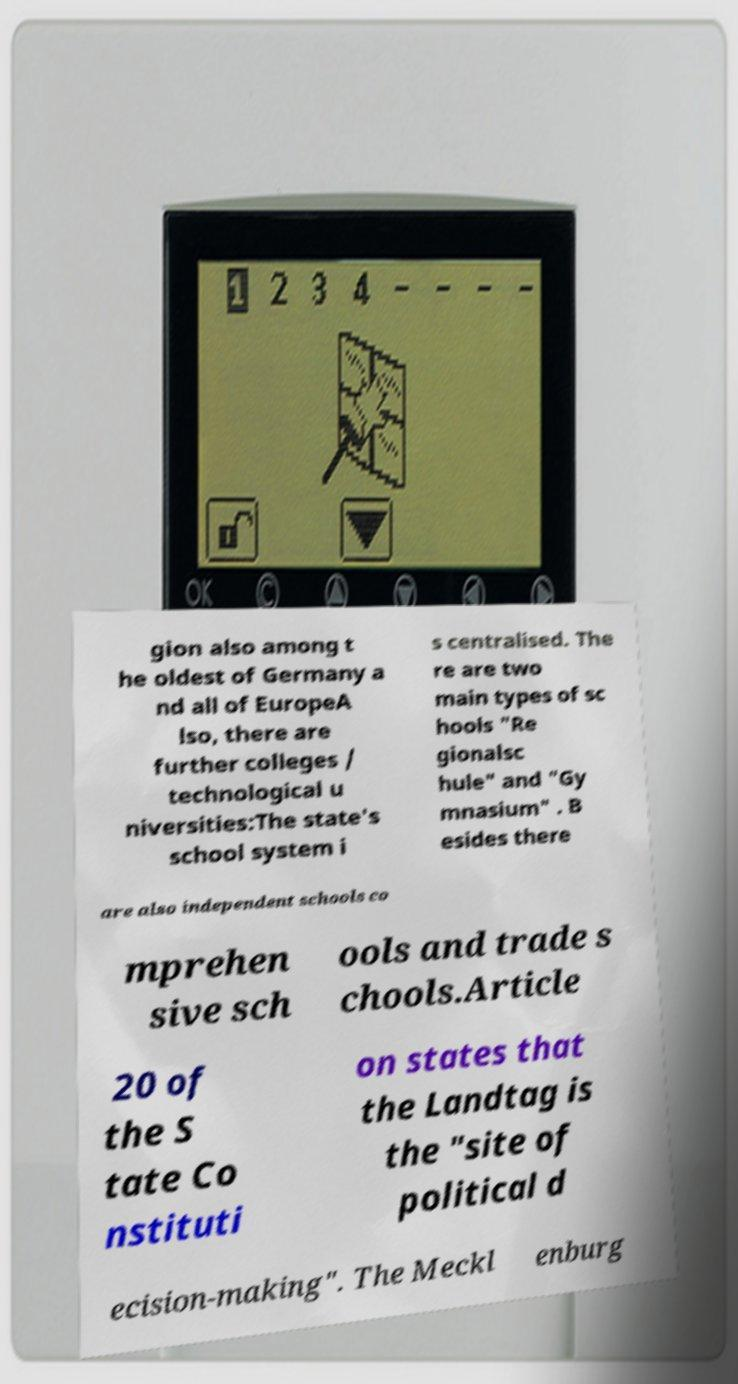Can you read and provide the text displayed in the image?This photo seems to have some interesting text. Can you extract and type it out for me? gion also among t he oldest of Germany a nd all of EuropeA lso, there are further colleges / technological u niversities:The state's school system i s centralised. The re are two main types of sc hools "Re gionalsc hule" and "Gy mnasium" . B esides there are also independent schools co mprehen sive sch ools and trade s chools.Article 20 of the S tate Co nstituti on states that the Landtag is the "site of political d ecision-making". The Meckl enburg 